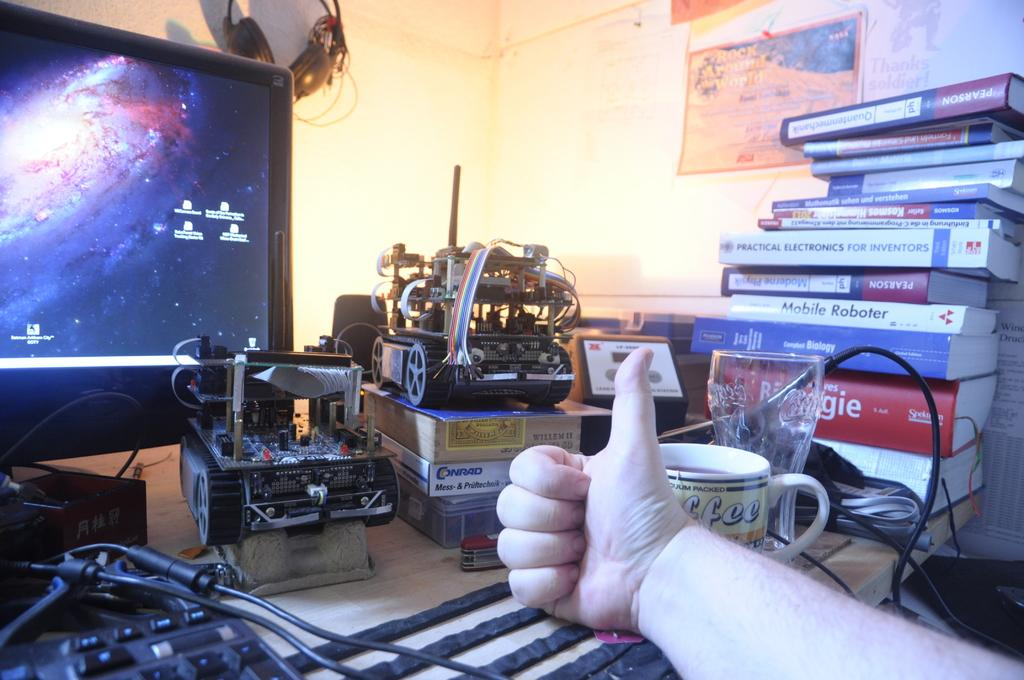<image>
Describe the image concisely. A stack of books on a desk includes Practical Electronics for Inventors. 